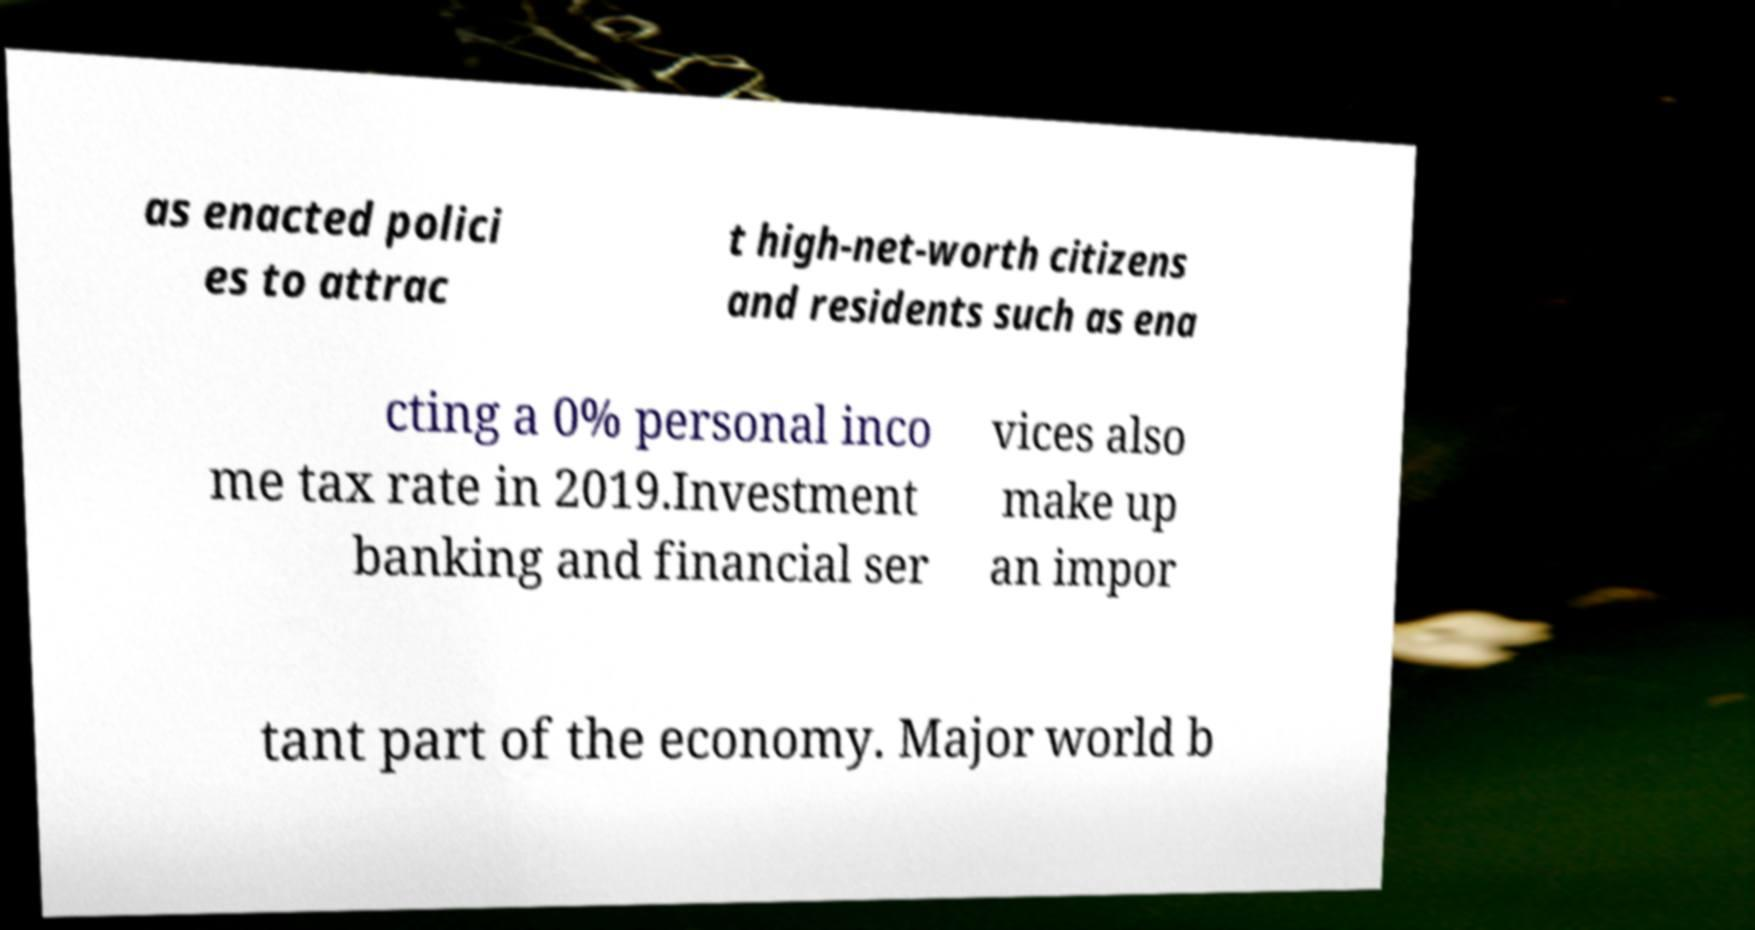What messages or text are displayed in this image? I need them in a readable, typed format. as enacted polici es to attrac t high-net-worth citizens and residents such as ena cting a 0% personal inco me tax rate in 2019.Investment banking and financial ser vices also make up an impor tant part of the economy. Major world b 